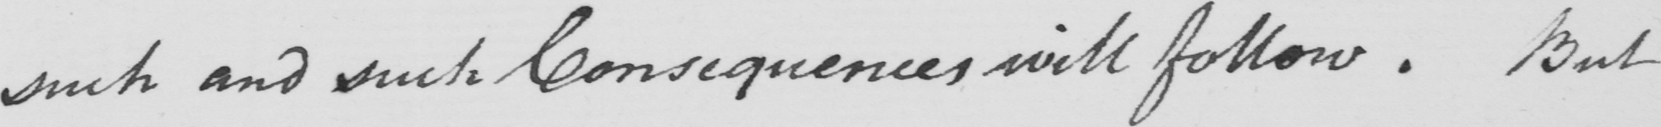What text is written in this handwritten line? such and such Consequences will follow. But 